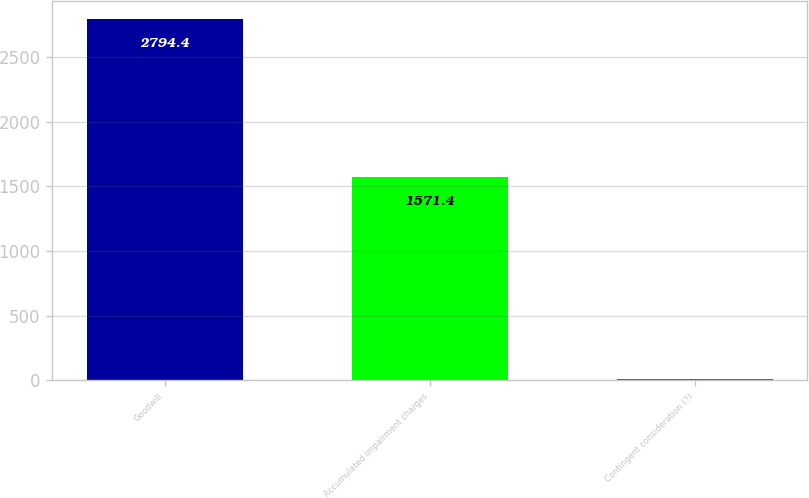Convert chart. <chart><loc_0><loc_0><loc_500><loc_500><bar_chart><fcel>Goodwill<fcel>Accumulated impairment charges<fcel>Contingent consideration (2)<nl><fcel>2794.4<fcel>1571.4<fcel>8.8<nl></chart> 